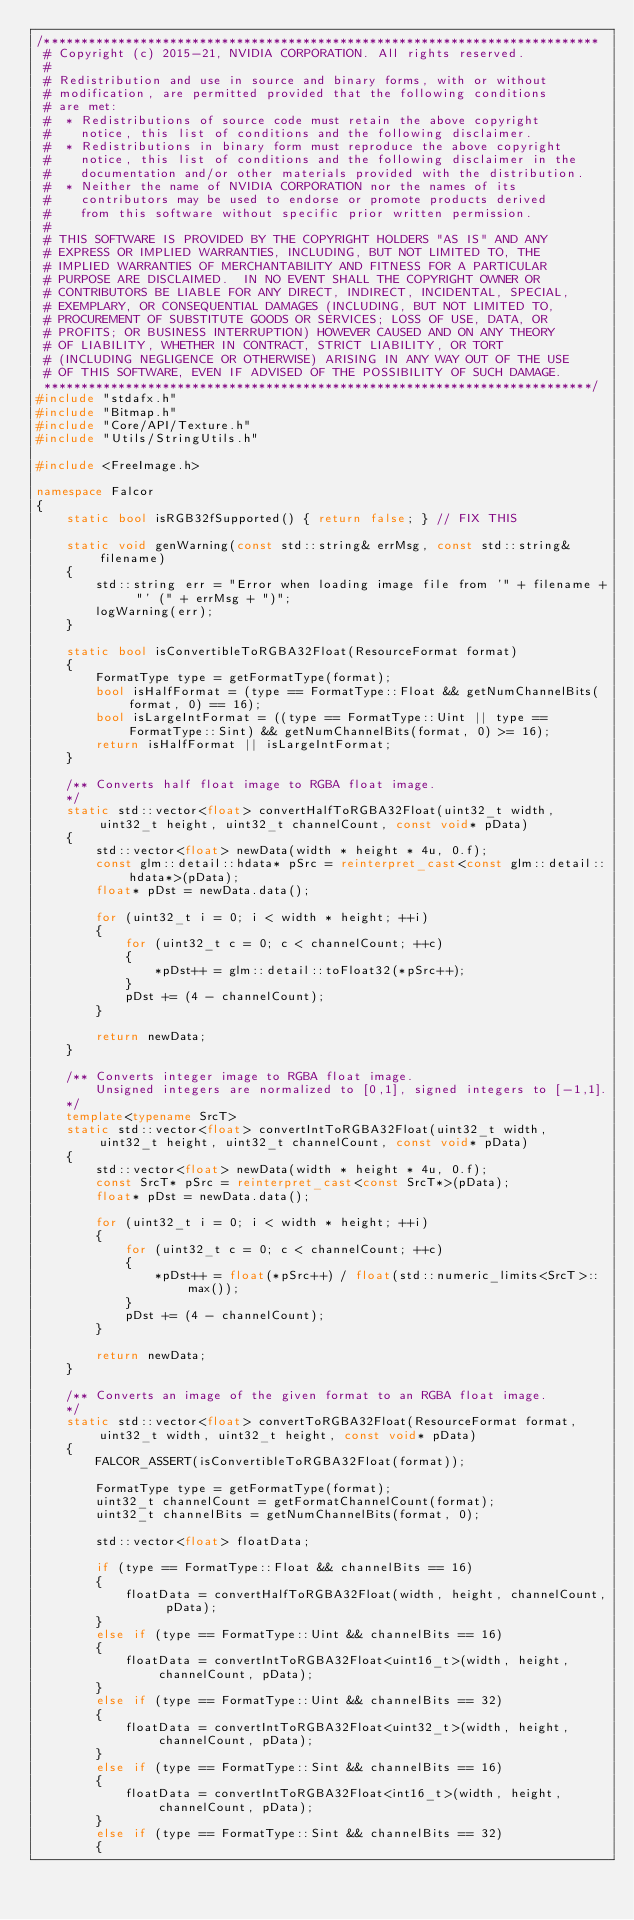Convert code to text. <code><loc_0><loc_0><loc_500><loc_500><_C++_>/***************************************************************************
 # Copyright (c) 2015-21, NVIDIA CORPORATION. All rights reserved.
 #
 # Redistribution and use in source and binary forms, with or without
 # modification, are permitted provided that the following conditions
 # are met:
 #  * Redistributions of source code must retain the above copyright
 #    notice, this list of conditions and the following disclaimer.
 #  * Redistributions in binary form must reproduce the above copyright
 #    notice, this list of conditions and the following disclaimer in the
 #    documentation and/or other materials provided with the distribution.
 #  * Neither the name of NVIDIA CORPORATION nor the names of its
 #    contributors may be used to endorse or promote products derived
 #    from this software without specific prior written permission.
 #
 # THIS SOFTWARE IS PROVIDED BY THE COPYRIGHT HOLDERS "AS IS" AND ANY
 # EXPRESS OR IMPLIED WARRANTIES, INCLUDING, BUT NOT LIMITED TO, THE
 # IMPLIED WARRANTIES OF MERCHANTABILITY AND FITNESS FOR A PARTICULAR
 # PURPOSE ARE DISCLAIMED.  IN NO EVENT SHALL THE COPYRIGHT OWNER OR
 # CONTRIBUTORS BE LIABLE FOR ANY DIRECT, INDIRECT, INCIDENTAL, SPECIAL,
 # EXEMPLARY, OR CONSEQUENTIAL DAMAGES (INCLUDING, BUT NOT LIMITED TO,
 # PROCUREMENT OF SUBSTITUTE GOODS OR SERVICES; LOSS OF USE, DATA, OR
 # PROFITS; OR BUSINESS INTERRUPTION) HOWEVER CAUSED AND ON ANY THEORY
 # OF LIABILITY, WHETHER IN CONTRACT, STRICT LIABILITY, OR TORT
 # (INCLUDING NEGLIGENCE OR OTHERWISE) ARISING IN ANY WAY OUT OF THE USE
 # OF THIS SOFTWARE, EVEN IF ADVISED OF THE POSSIBILITY OF SUCH DAMAGE.
 **************************************************************************/
#include "stdafx.h"
#include "Bitmap.h"
#include "Core/API/Texture.h"
#include "Utils/StringUtils.h"

#include <FreeImage.h>

namespace Falcor
{
    static bool isRGB32fSupported() { return false; } // FIX THIS

    static void genWarning(const std::string& errMsg, const std::string& filename)
    {
        std::string err = "Error when loading image file from '" + filename + "' (" + errMsg + ")";
        logWarning(err);
    }

    static bool isConvertibleToRGBA32Float(ResourceFormat format)
    {
        FormatType type = getFormatType(format);
        bool isHalfFormat = (type == FormatType::Float && getNumChannelBits(format, 0) == 16);
        bool isLargeIntFormat = ((type == FormatType::Uint || type == FormatType::Sint) && getNumChannelBits(format, 0) >= 16);
        return isHalfFormat || isLargeIntFormat;
    }

    /** Converts half float image to RGBA float image.
    */
    static std::vector<float> convertHalfToRGBA32Float(uint32_t width, uint32_t height, uint32_t channelCount, const void* pData)
    {
        std::vector<float> newData(width * height * 4u, 0.f);
        const glm::detail::hdata* pSrc = reinterpret_cast<const glm::detail::hdata*>(pData);
        float* pDst = newData.data();

        for (uint32_t i = 0; i < width * height; ++i)
        {
            for (uint32_t c = 0; c < channelCount; ++c)
            {
                *pDst++ = glm::detail::toFloat32(*pSrc++);
            }
            pDst += (4 - channelCount);
        }

        return newData;
    }

    /** Converts integer image to RGBA float image.
        Unsigned integers are normalized to [0,1], signed integers to [-1,1].
    */
    template<typename SrcT>
    static std::vector<float> convertIntToRGBA32Float(uint32_t width, uint32_t height, uint32_t channelCount, const void* pData)
    {
        std::vector<float> newData(width * height * 4u, 0.f);
        const SrcT* pSrc = reinterpret_cast<const SrcT*>(pData);
        float* pDst = newData.data();

        for (uint32_t i = 0; i < width * height; ++i)
        {
            for (uint32_t c = 0; c < channelCount; ++c)
            {
                *pDst++ = float(*pSrc++) / float(std::numeric_limits<SrcT>::max());
            }
            pDst += (4 - channelCount);
        }

        return newData;
    }

    /** Converts an image of the given format to an RGBA float image.
    */
    static std::vector<float> convertToRGBA32Float(ResourceFormat format, uint32_t width, uint32_t height, const void* pData)
    {
        FALCOR_ASSERT(isConvertibleToRGBA32Float(format));

        FormatType type = getFormatType(format);
        uint32_t channelCount = getFormatChannelCount(format);
        uint32_t channelBits = getNumChannelBits(format, 0);

        std::vector<float> floatData;

        if (type == FormatType::Float && channelBits == 16)
        {
            floatData = convertHalfToRGBA32Float(width, height, channelCount, pData);
        }
        else if (type == FormatType::Uint && channelBits == 16)
        {
            floatData = convertIntToRGBA32Float<uint16_t>(width, height, channelCount, pData);
        }
        else if (type == FormatType::Uint && channelBits == 32)
        {
            floatData = convertIntToRGBA32Float<uint32_t>(width, height, channelCount, pData);
        }
        else if (type == FormatType::Sint && channelBits == 16)
        {
            floatData = convertIntToRGBA32Float<int16_t>(width, height, channelCount, pData);
        }
        else if (type == FormatType::Sint && channelBits == 32)
        {</code> 